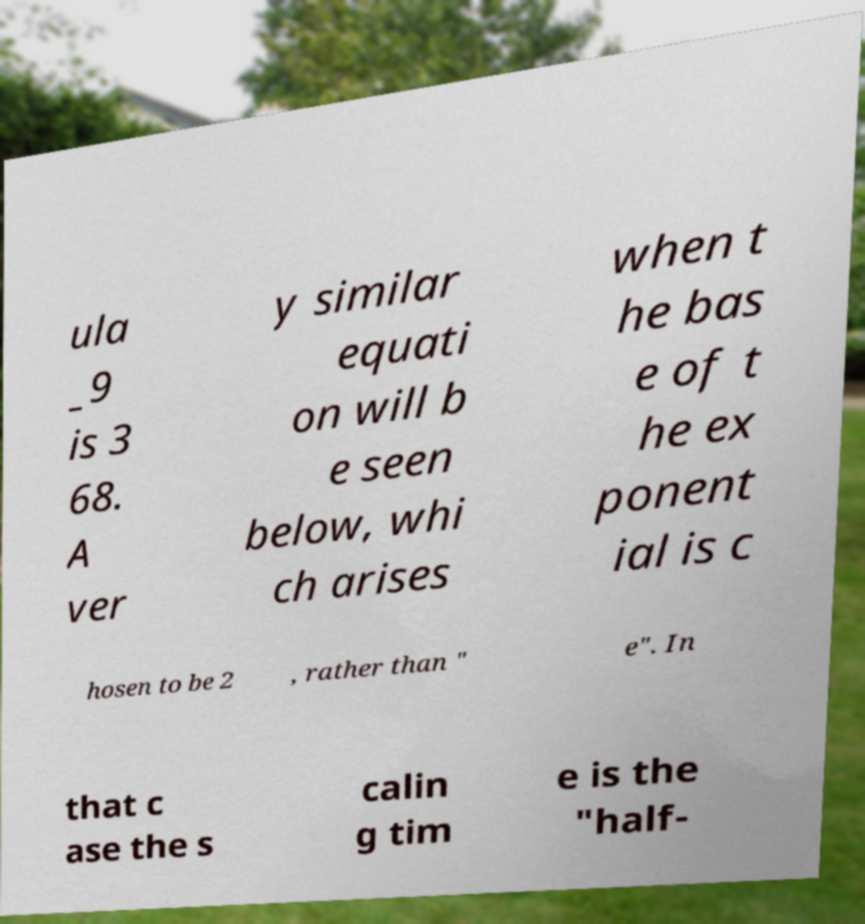Please identify and transcribe the text found in this image. ula _9 is 3 68. A ver y similar equati on will b e seen below, whi ch arises when t he bas e of t he ex ponent ial is c hosen to be 2 , rather than " e". In that c ase the s calin g tim e is the "half- 